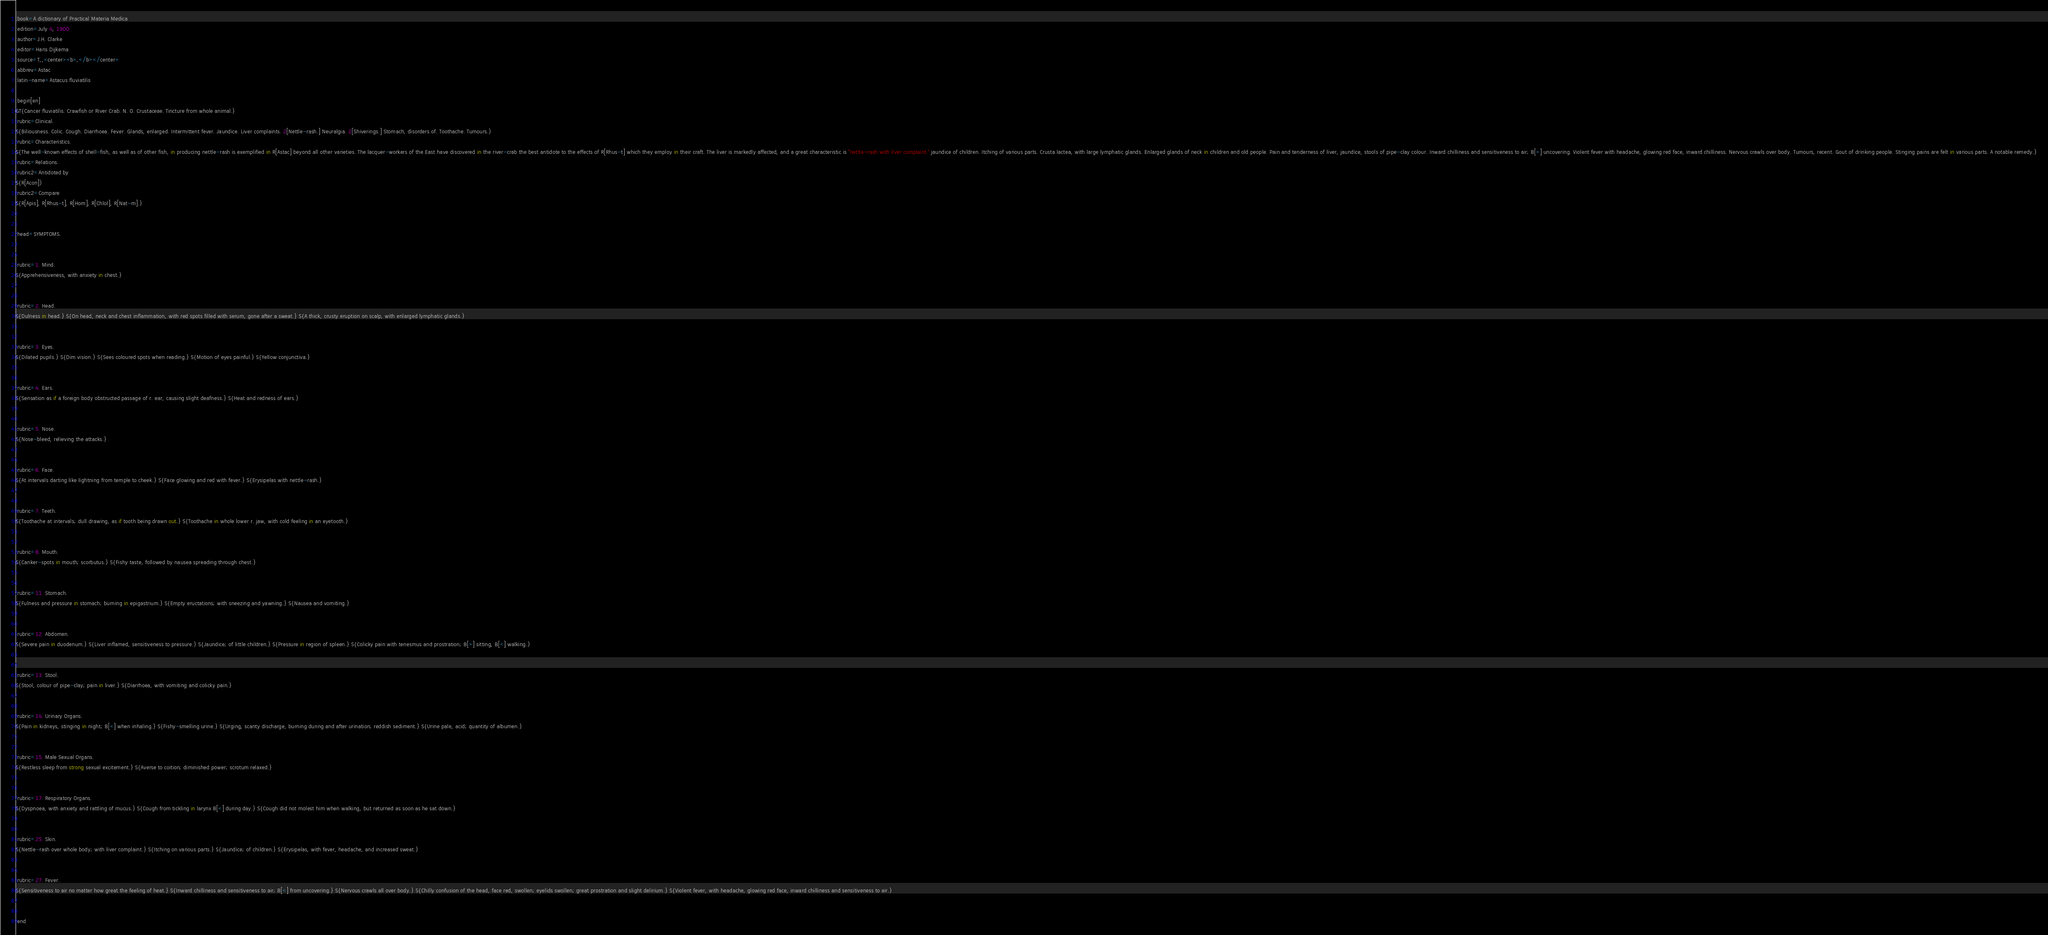Convert code to text. <code><loc_0><loc_0><loc_500><loc_500><_ObjectiveC_>:book=A dictionary of Practical Materia Medica
:edition=July 4, 1900
:author=J.H. Clarke
:editor=Hans Dijkema
:source=T,,<center><b>,</b></center>
:abbrev=Astac
:latin-name=Astacus fluviatilis

:begin[en]
GT{Cancer fluviatilis. Crawfish or River Crab. N. O. Crustaceae. Tincture from whole animal.}
:rubric=Clinical.
S{Biliousness. Colic. Cough. Diarrhoea. Fever. Glands, enlarged. Intermittent fever. Jaundice. Liver complaints. 2[Nettle-rash.] Neuralgia. 2[Shiverings.] Stomach, disorders of. Toothache. Tumours.}
:rubric=Characteristics.
S{The well-known effects of shell-fish, as well as of other fish, in producing nettle-rash is exemplified in R[Astac] beyond all other varieties. The lacquer-workers of the East have discovered in the river-crab the best antidote to the effects of R[Rhus-t] which they employ in their craft. The liver is markedly affected, and a great characteristic is "nettle-rash with liver complaint." jaundice of children. Itching of various parts. Crusta lactea, with large lymphatic glands. Enlarged glands of neck in children and old people. Pain and tenderness of liver, jaundice, stools of pipe-clay colour. Inward chilliness and sensitiveness to air; B[<] uncovering. Violent fever with headache, glowing red face, inward chilliness. Nervous crawls over body. Tumours, recent. Gout of drinking people. Stinging pains are felt in various parts. A notable remedy.}
:rubric=Relations.
:rubric2=Antidoted by
S{R[Acon]}
:rubric2=Compare
S{R[Apis], R[Rhus-t], R[Hom], R[Chlol], R[Nat-m].}


:head=SYMPTOMS.


:rubric=1. Mind.
S{Apprehensiveness, with anxiety in chest.}


:rubric=2. Head.
S{Dulness in head.} S{On head, neck and chest inflammation, with red spots filled with serum, gone after a sweat.} S{A thick, crusty eruption on scalp, with enlarged lymphatic glands.}


:rubric=3. Eyes.
S{Dilated pupils.} S{Dim vision.} S{Sees coloured spots when reading.} S{Motion of eyes painful.} S{Yellow conjunctiva.}


:rubric=4. Ears.
S{Sensation as if a foreign body obstructed passage of r. ear, causing slight deafness.} S{Heat and redness of ears.}


:rubric=5. Nose.
S{Nose-bleed, relieving the attacks.}


:rubric=6. Face.
S{At intervals darting like lightning from temple to cheek.} S{Face glowing and red with fever.} S{Erysipelas with nettle-rash.}


:rubric=7. Teeth.
S{Toothache at intervals; dull drawing, as if tooth being drawn out.} S{Toothache in whole lower r. jaw, with cold feeling in an eyetooth.}


:rubric=8. Mouth.
S{Canker-spots in mouth; scorbutus.} S{Fishy taste, followed by nausea spreading through chest.}


:rubric=11. Stomach.
S{Fulness and pressure in stomach; burning in epigastrium.} S{Empty eructations; with sneezing and yawning.} S{Nausea and vomiting.}


:rubric=12. Abdomen.
S{Severe pain in duodenum.} S{Liver inflamed, sensitiveness to pressure.} S{Jaundice; of little children.} S{Pressure in region of spleen.} S{Colicky pain with tenesmus and prostration; B[>] sitting, B[<] walking.}


:rubric=13. Stool.
S{Stool, colour of pipe-clay; pain in liver.} S{Diarrhoea, with vomiting and colicky pain.}


:rubric=14. Urinary Organs.
S{Pain in kidneys, stinging in night; B[<] when inhaling.} S{Fishy-smelling urine.} S{Urging, scanty discharge, burning during and after urination; reddish sediment.} S{Urine pale, acid; quantity of albumen.}


:rubric=15. Male Sexual Organs.
S{Restless sleep from strong sexual excitement.} S{Averse to coition; diminished power; scrotum relaxed.}


:rubric=17. Respiratory Organs.
S{Dyspnoea, with anxiety and rattling of mucus.} S{Cough from tickling in larynx B[<] during day.} S{Cough did not molest him when walking, but returned as soon as he sat down.}


:rubric=25. Skin.
S{Nettle-rash over whole body; with liver complaint.} S{Itching on various parts.} S{Jaundice; of children.} S{Erysipelas, with fever, headache, and increased sweat.}


:rubric=27. Fever.
S{Sensitiveness to air no matter how great the feeling of heat.} S{Inward chilliness and sensitiveness to air; B[<] from uncovering.} S{Nervous crawls all over body.} S{Chilly confusion of the head, face red, swollen; eyelids swollen; great prostration and slight delirium.} S{Violent fever, with headache, glowing red face, inward chilliness and sensitiveness to air.}

  
:end</code> 